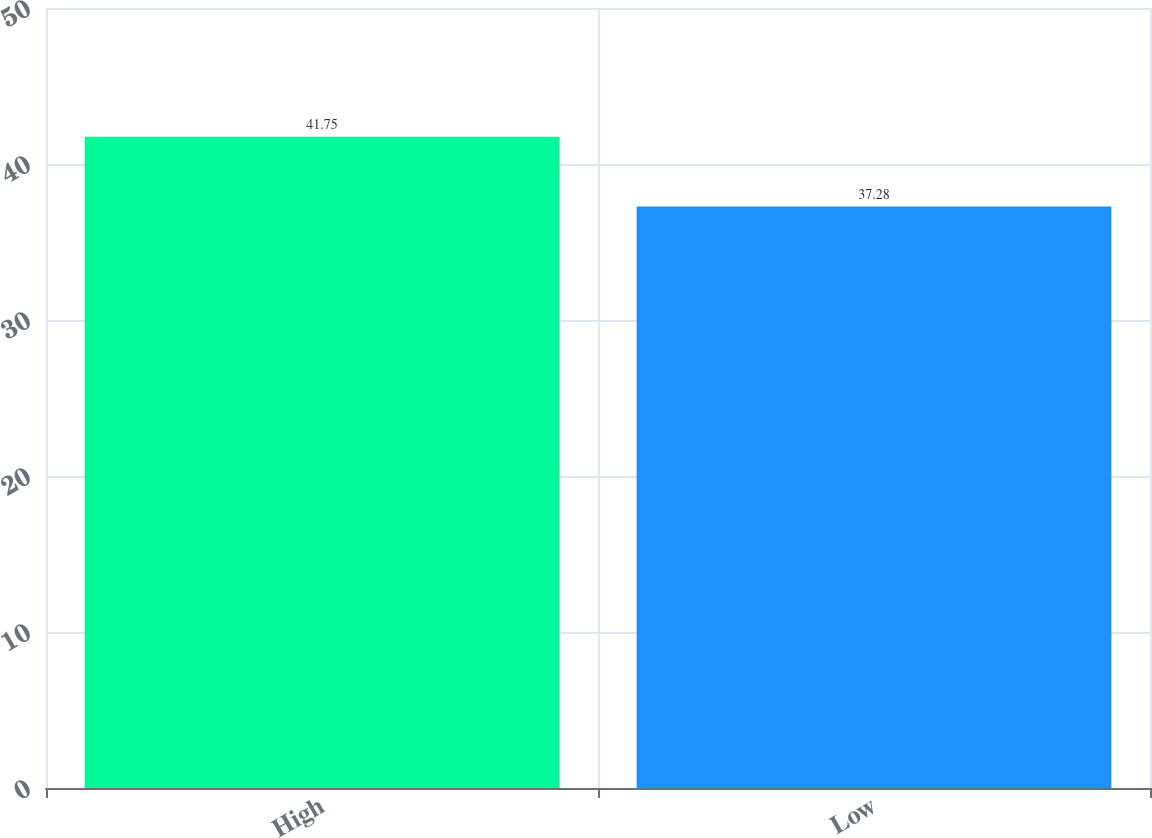Convert chart. <chart><loc_0><loc_0><loc_500><loc_500><bar_chart><fcel>High<fcel>Low<nl><fcel>41.75<fcel>37.28<nl></chart> 